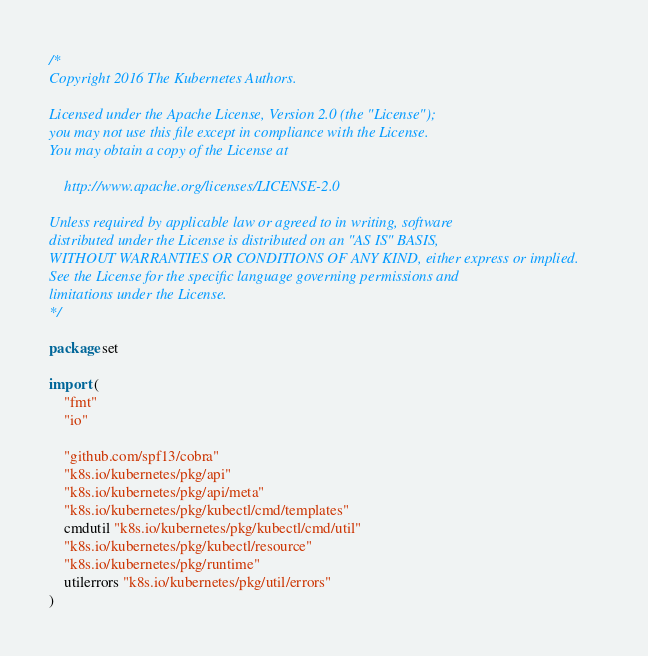Convert code to text. <code><loc_0><loc_0><loc_500><loc_500><_Go_>/*
Copyright 2016 The Kubernetes Authors.

Licensed under the Apache License, Version 2.0 (the "License");
you may not use this file except in compliance with the License.
You may obtain a copy of the License at

    http://www.apache.org/licenses/LICENSE-2.0

Unless required by applicable law or agreed to in writing, software
distributed under the License is distributed on an "AS IS" BASIS,
WITHOUT WARRANTIES OR CONDITIONS OF ANY KIND, either express or implied.
See the License for the specific language governing permissions and
limitations under the License.
*/

package set

import (
	"fmt"
	"io"

	"github.com/spf13/cobra"
	"k8s.io/kubernetes/pkg/api"
	"k8s.io/kubernetes/pkg/api/meta"
	"k8s.io/kubernetes/pkg/kubectl/cmd/templates"
	cmdutil "k8s.io/kubernetes/pkg/kubectl/cmd/util"
	"k8s.io/kubernetes/pkg/kubectl/resource"
	"k8s.io/kubernetes/pkg/runtime"
	utilerrors "k8s.io/kubernetes/pkg/util/errors"
)
</code> 